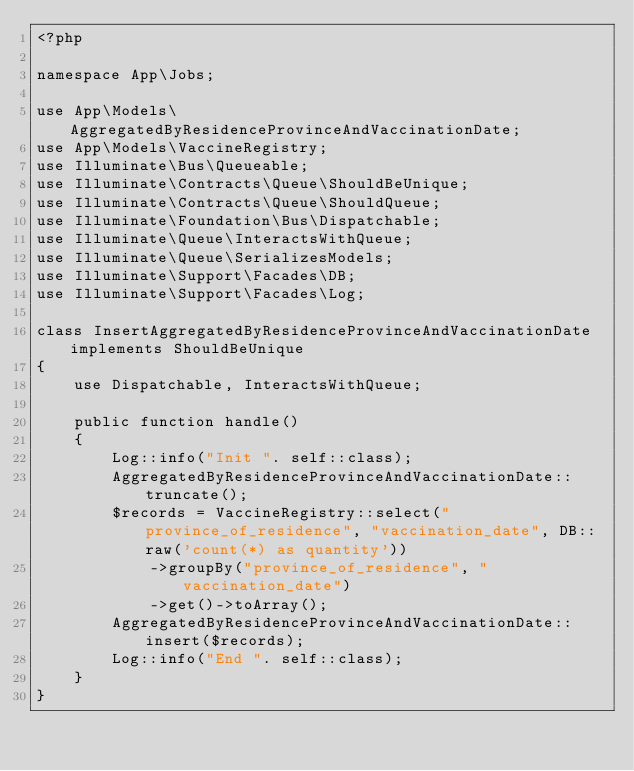Convert code to text. <code><loc_0><loc_0><loc_500><loc_500><_PHP_><?php

namespace App\Jobs;

use App\Models\AggregatedByResidenceProvinceAndVaccinationDate;
use App\Models\VaccineRegistry;
use Illuminate\Bus\Queueable;
use Illuminate\Contracts\Queue\ShouldBeUnique;
use Illuminate\Contracts\Queue\ShouldQueue;
use Illuminate\Foundation\Bus\Dispatchable;
use Illuminate\Queue\InteractsWithQueue;
use Illuminate\Queue\SerializesModels;
use Illuminate\Support\Facades\DB;
use Illuminate\Support\Facades\Log;

class InsertAggregatedByResidenceProvinceAndVaccinationDate implements ShouldBeUnique
{
    use Dispatchable, InteractsWithQueue;

    public function handle()
    {
        Log::info("Init ". self::class);
        AggregatedByResidenceProvinceAndVaccinationDate::truncate();
        $records = VaccineRegistry::select("province_of_residence", "vaccination_date", DB::raw('count(*) as quantity'))
            ->groupBy("province_of_residence", "vaccination_date")
            ->get()->toArray();
        AggregatedByResidenceProvinceAndVaccinationDate::insert($records);
        Log::info("End ". self::class);
    }
}
</code> 